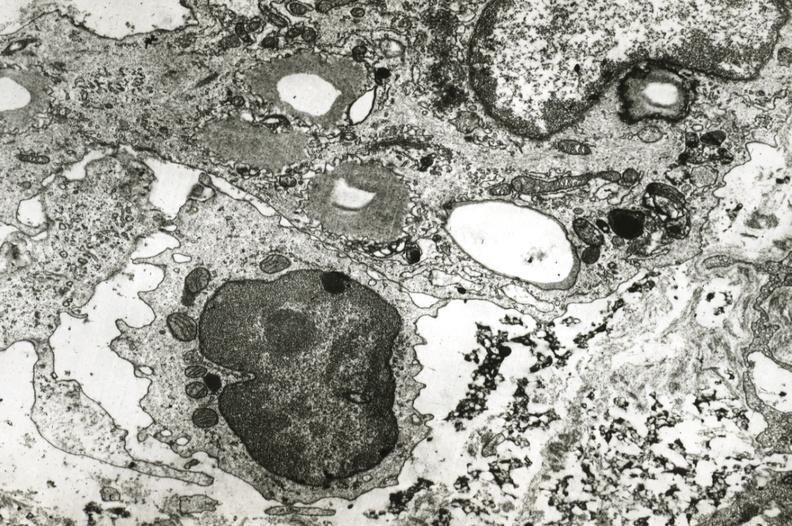s cardiovascular present?
Answer the question using a single word or phrase. Yes 